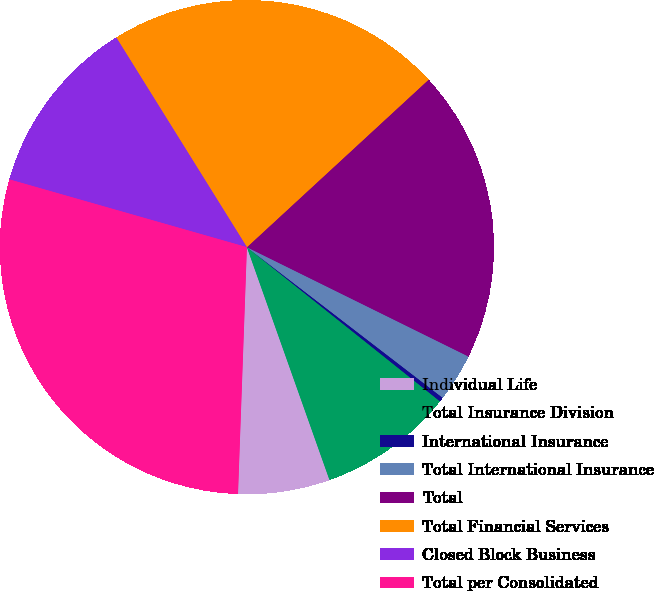Convert chart to OTSL. <chart><loc_0><loc_0><loc_500><loc_500><pie_chart><fcel>Individual Life<fcel>Total Insurance Division<fcel>International Insurance<fcel>Total International Insurance<fcel>Total<fcel>Total Financial Services<fcel>Closed Block Business<fcel>Total per Consolidated<nl><fcel>6.0%<fcel>8.85%<fcel>0.29%<fcel>3.14%<fcel>19.15%<fcel>22.01%<fcel>11.71%<fcel>28.85%<nl></chart> 